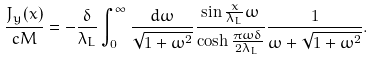<formula> <loc_0><loc_0><loc_500><loc_500>\frac { J _ { y } ( x ) } { c M } = - \frac { \delta } { \lambda _ { L } } \int _ { 0 } ^ { \infty } \frac { d \omega } { \sqrt { 1 + \omega ^ { 2 } } } \frac { \sin \frac { x } { \lambda _ { L } } \omega } { \cosh \frac { \pi \omega \delta } { 2 \lambda _ { L } } } \frac { 1 } { \omega + \sqrt { 1 + \omega ^ { 2 } } } .</formula> 